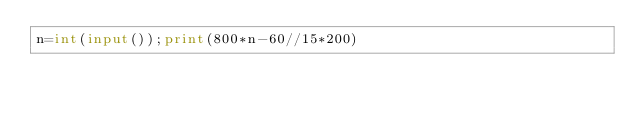Convert code to text. <code><loc_0><loc_0><loc_500><loc_500><_Python_>n=int(input());print(800*n-60//15*200)</code> 